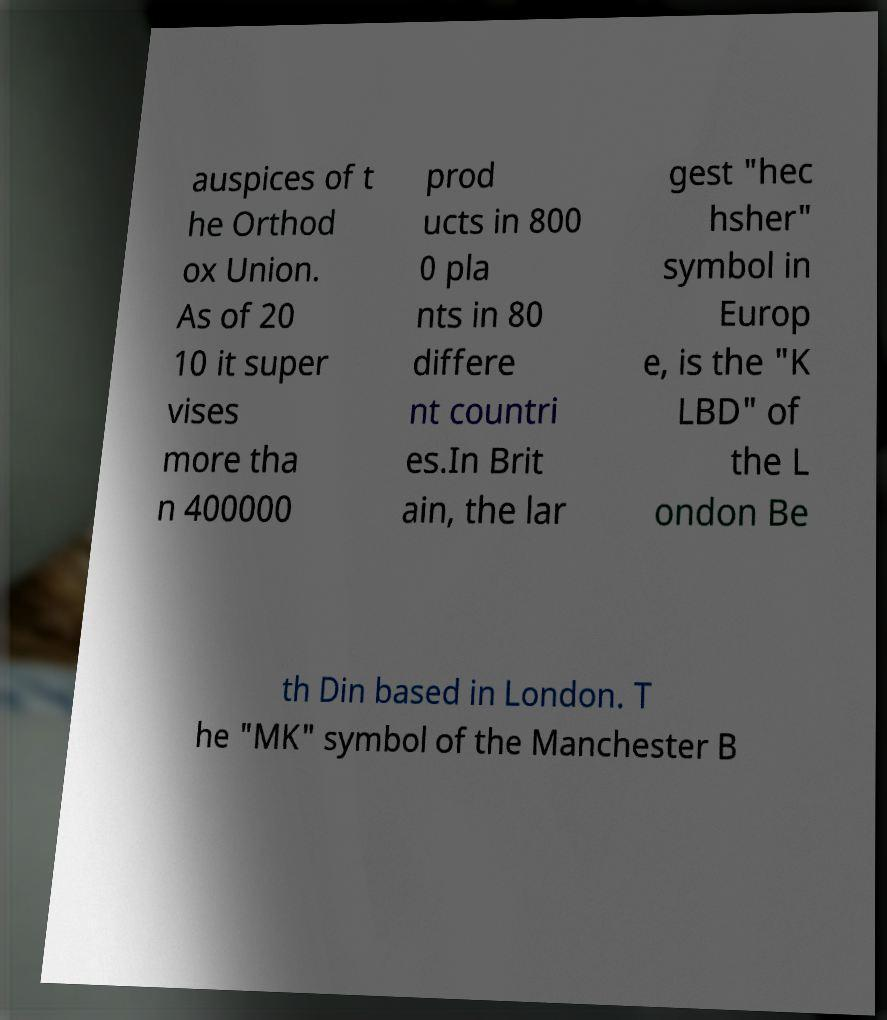Could you extract and type out the text from this image? auspices of t he Orthod ox Union. As of 20 10 it super vises more tha n 400000 prod ucts in 800 0 pla nts in 80 differe nt countri es.In Brit ain, the lar gest "hec hsher" symbol in Europ e, is the "K LBD" of the L ondon Be th Din based in London. T he "MK" symbol of the Manchester B 